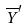<formula> <loc_0><loc_0><loc_500><loc_500>\overline { Y } ^ { \prime }</formula> 